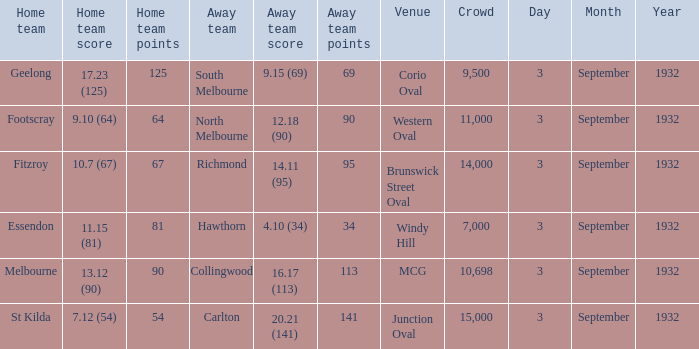What is the Home team score for the Away team of North Melbourne? 9.10 (64). 